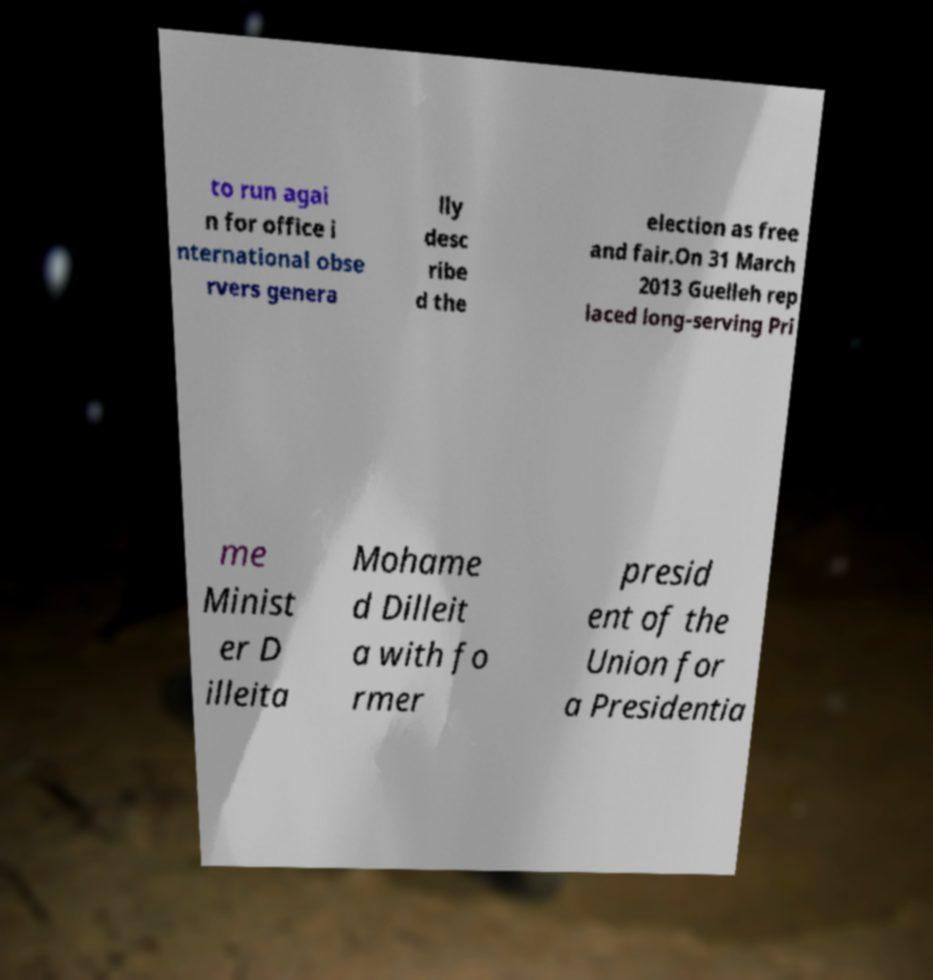Can you read and provide the text displayed in the image?This photo seems to have some interesting text. Can you extract and type it out for me? to run agai n for office i nternational obse rvers genera lly desc ribe d the election as free and fair.On 31 March 2013 Guelleh rep laced long-serving Pri me Minist er D illeita Mohame d Dilleit a with fo rmer presid ent of the Union for a Presidentia 